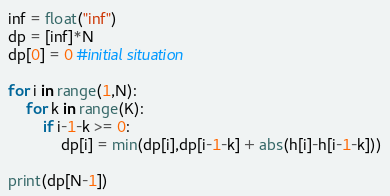<code> <loc_0><loc_0><loc_500><loc_500><_Python_>
inf = float("inf")
dp = [inf]*N
dp[0] = 0 #initial situation

for i in range(1,N):
	for k in range(K):
		if i-1-k >= 0:
			dp[i] = min(dp[i],dp[i-1-k] + abs(h[i]-h[i-1-k]))
			
print(dp[N-1])</code> 